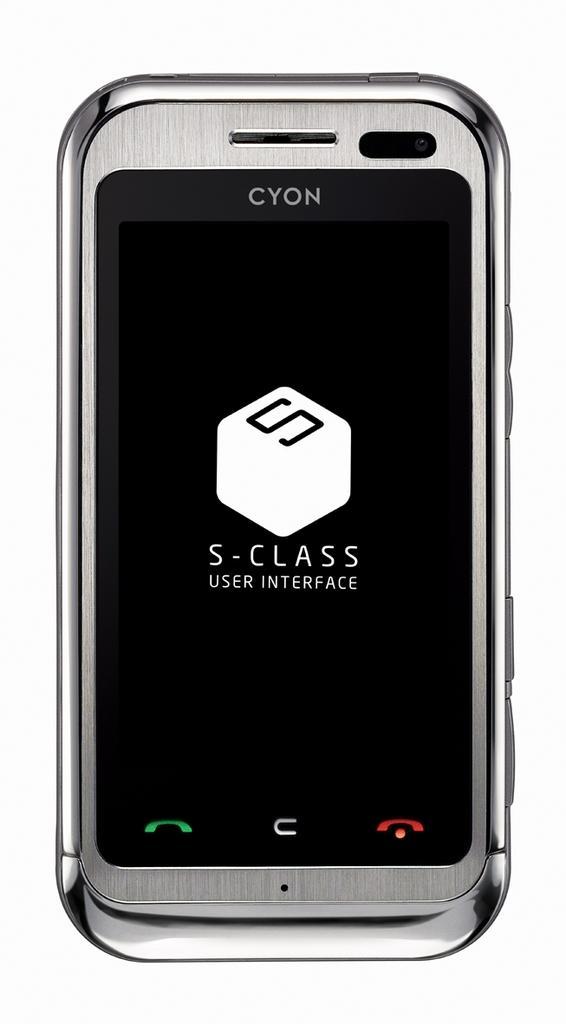In one or two sentences, can you explain what this image depicts? In the picture there is a mobile phone present, on the screen of the mobile there is some text. 